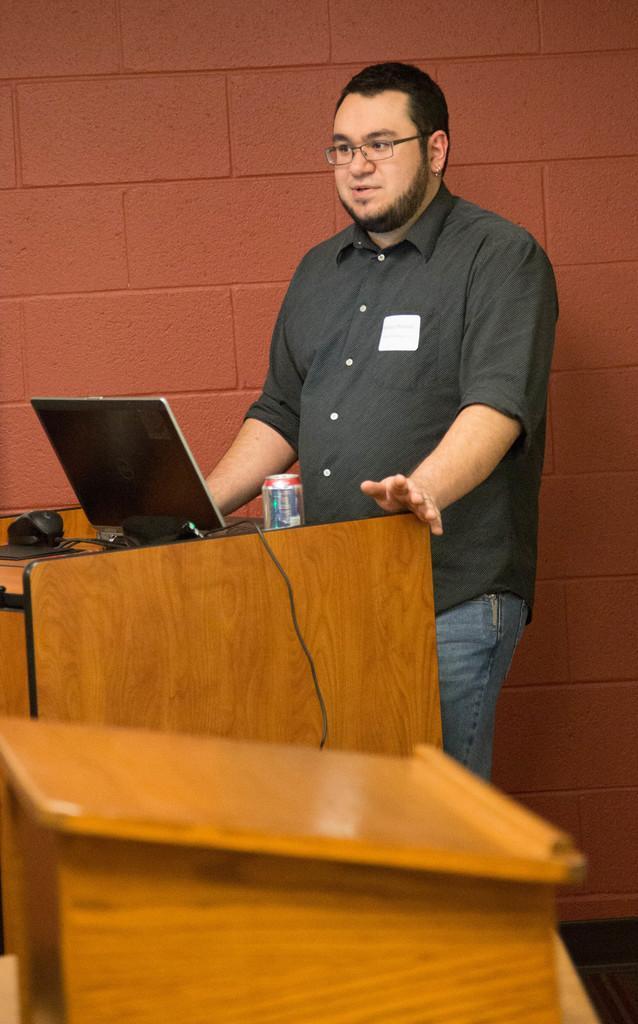Please provide a concise description of this image. In this picture a guy is standing in front of a brown color table and there is a laptop on top of it. There is a red color wall in the background. 